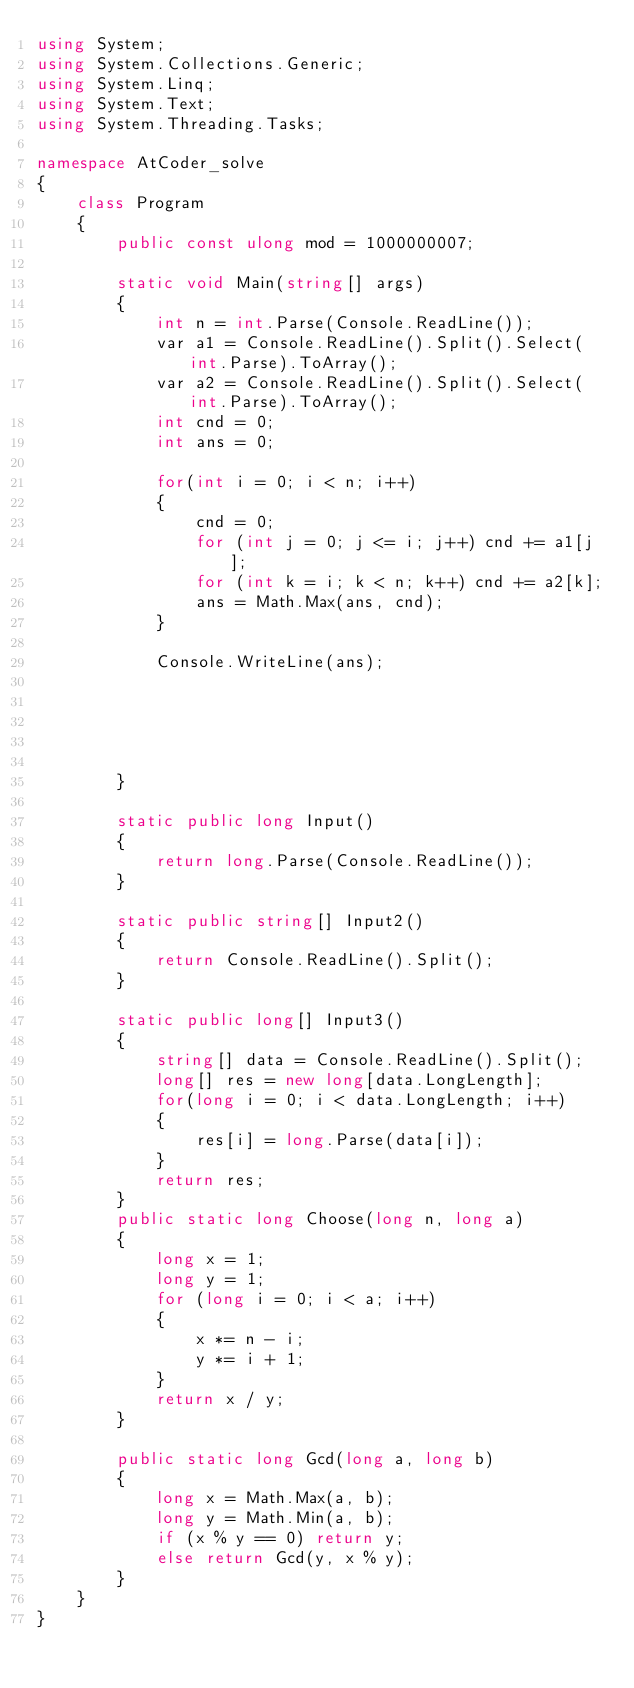<code> <loc_0><loc_0><loc_500><loc_500><_C#_>using System;
using System.Collections.Generic;
using System.Linq;
using System.Text;
using System.Threading.Tasks;

namespace AtCoder_solve
{
    class Program
    {
        public const ulong mod = 1000000007;

        static void Main(string[] args)
        {
            int n = int.Parse(Console.ReadLine());
            var a1 = Console.ReadLine().Split().Select(int.Parse).ToArray();
            var a2 = Console.ReadLine().Split().Select(int.Parse).ToArray();
            int cnd = 0;
            int ans = 0;

            for(int i = 0; i < n; i++)
            {
                cnd = 0;
                for (int j = 0; j <= i; j++) cnd += a1[j]; 
                for (int k = i; k < n; k++) cnd += a2[k]; 
                ans = Math.Max(ans, cnd);
            }

            Console.WriteLine(ans);

            


            
        }

        static public long Input()
        {
            return long.Parse(Console.ReadLine());
        }

        static public string[] Input2()
        {
            return Console.ReadLine().Split();
        }
        
        static public long[] Input3()
        {
            string[] data = Console.ReadLine().Split();
            long[] res = new long[data.LongLength];
            for(long i = 0; i < data.LongLength; i++)
            {
                res[i] = long.Parse(data[i]);
            }
            return res;
        }
        public static long Choose(long n, long a)
        {
            long x = 1;
            long y = 1;
            for (long i = 0; i < a; i++)
            {
                x *= n - i;
                y *= i + 1;
            }
            return x / y;
        }

        public static long Gcd(long a, long b)
        {
            long x = Math.Max(a, b);
            long y = Math.Min(a, b);
            if (x % y == 0) return y;
            else return Gcd(y, x % y);
        }
    }
}
</code> 